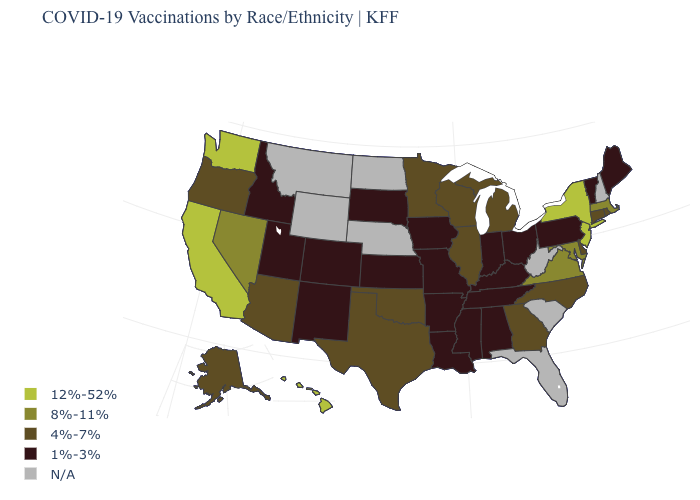Name the states that have a value in the range 1%-3%?
Give a very brief answer. Alabama, Arkansas, Colorado, Idaho, Indiana, Iowa, Kansas, Kentucky, Louisiana, Maine, Mississippi, Missouri, New Mexico, Ohio, Pennsylvania, South Dakota, Tennessee, Utah, Vermont. What is the value of Kentucky?
Be succinct. 1%-3%. Does the first symbol in the legend represent the smallest category?
Give a very brief answer. No. How many symbols are there in the legend?
Concise answer only. 5. Which states have the lowest value in the USA?
Write a very short answer. Alabama, Arkansas, Colorado, Idaho, Indiana, Iowa, Kansas, Kentucky, Louisiana, Maine, Mississippi, Missouri, New Mexico, Ohio, Pennsylvania, South Dakota, Tennessee, Utah, Vermont. Does the map have missing data?
Be succinct. Yes. Name the states that have a value in the range 8%-11%?
Quick response, please. Maryland, Massachusetts, Nevada, Virginia. What is the value of Mississippi?
Quick response, please. 1%-3%. Name the states that have a value in the range N/A?
Keep it brief. Florida, Montana, Nebraska, New Hampshire, North Dakota, South Carolina, West Virginia, Wyoming. Which states have the lowest value in the USA?
Be succinct. Alabama, Arkansas, Colorado, Idaho, Indiana, Iowa, Kansas, Kentucky, Louisiana, Maine, Mississippi, Missouri, New Mexico, Ohio, Pennsylvania, South Dakota, Tennessee, Utah, Vermont. Which states have the highest value in the USA?
Concise answer only. California, Hawaii, New Jersey, New York, Washington. Name the states that have a value in the range 4%-7%?
Concise answer only. Alaska, Arizona, Connecticut, Delaware, Georgia, Illinois, Michigan, Minnesota, North Carolina, Oklahoma, Oregon, Rhode Island, Texas, Wisconsin. Among the states that border Delaware , does Maryland have the highest value?
Quick response, please. No. Is the legend a continuous bar?
Answer briefly. No. What is the lowest value in states that border Delaware?
Give a very brief answer. 1%-3%. 